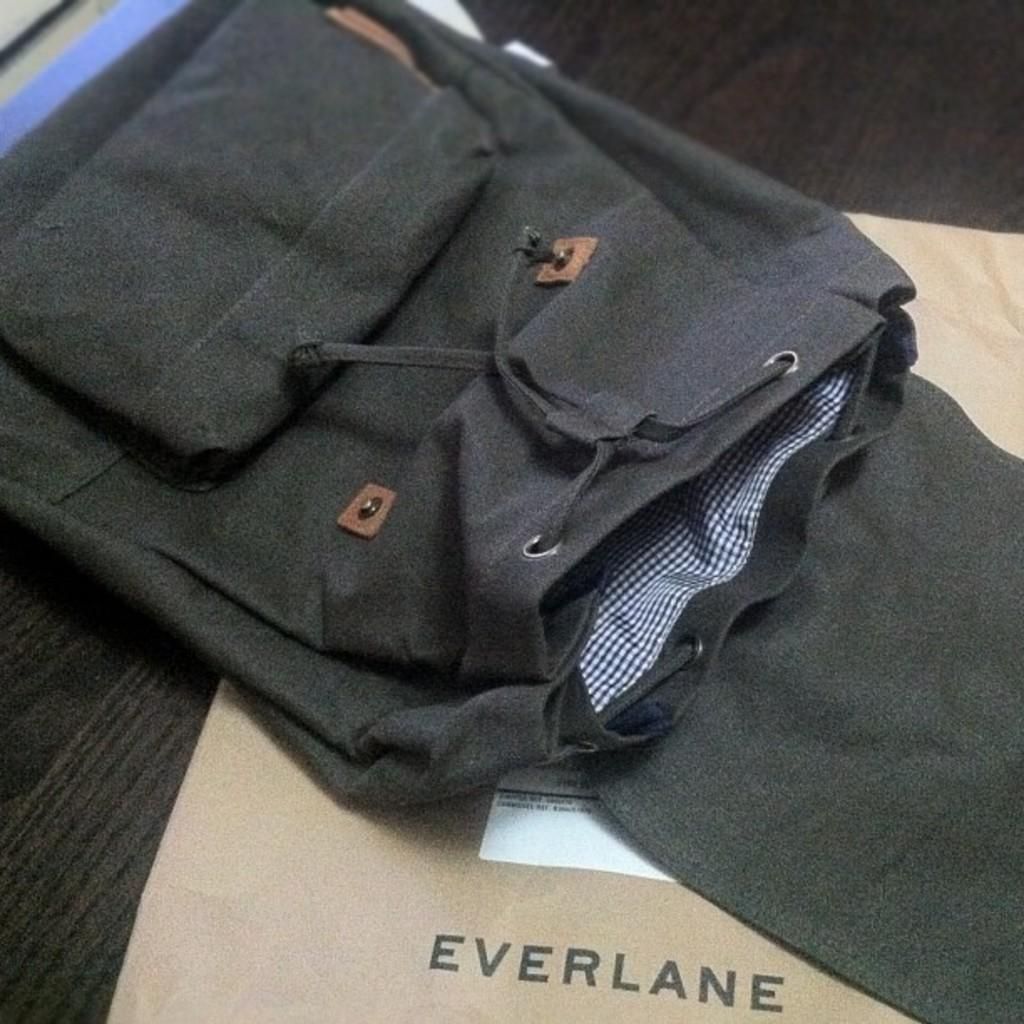What object can be seen in the image in the image? There is a bag in the image. What else is present in the image besides the bag? There is a cover in the image. On what surface are the bag and cover placed? The bag and cover are placed on a wooden surface. What is the rate of the protest happening near the pump in the image? There is no protest or pump present in the image; it only features a bag and a cover on a wooden surface. 